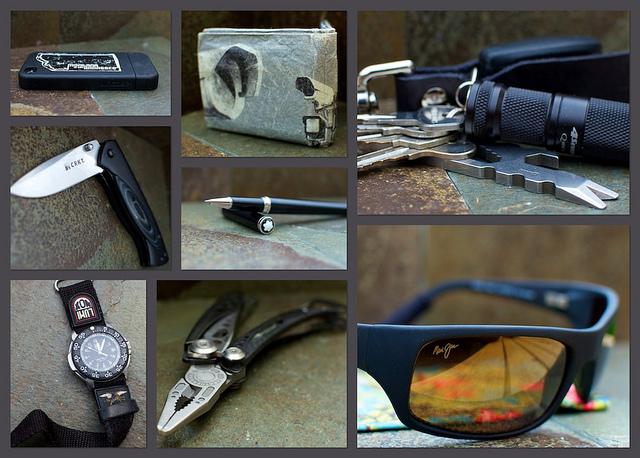What kind of person would use these objects?
Answer briefly. Man. What object is propping up the pen?
Write a very short answer. Pen. Could a photo like this be taken without any image manipulation?
Be succinct. No. 